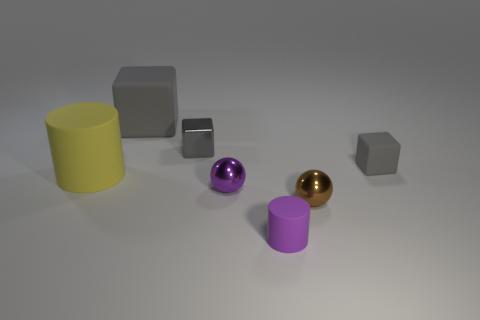Subtract all large matte cubes. How many cubes are left? 2 Add 1 tiny gray shiny blocks. How many objects exist? 8 Subtract all cubes. How many objects are left? 4 Subtract all red cubes. Subtract all green balls. How many cubes are left? 3 Subtract all small metal spheres. Subtract all shiny things. How many objects are left? 2 Add 4 large objects. How many large objects are left? 6 Add 7 tiny cylinders. How many tiny cylinders exist? 8 Subtract 0 green cubes. How many objects are left? 7 